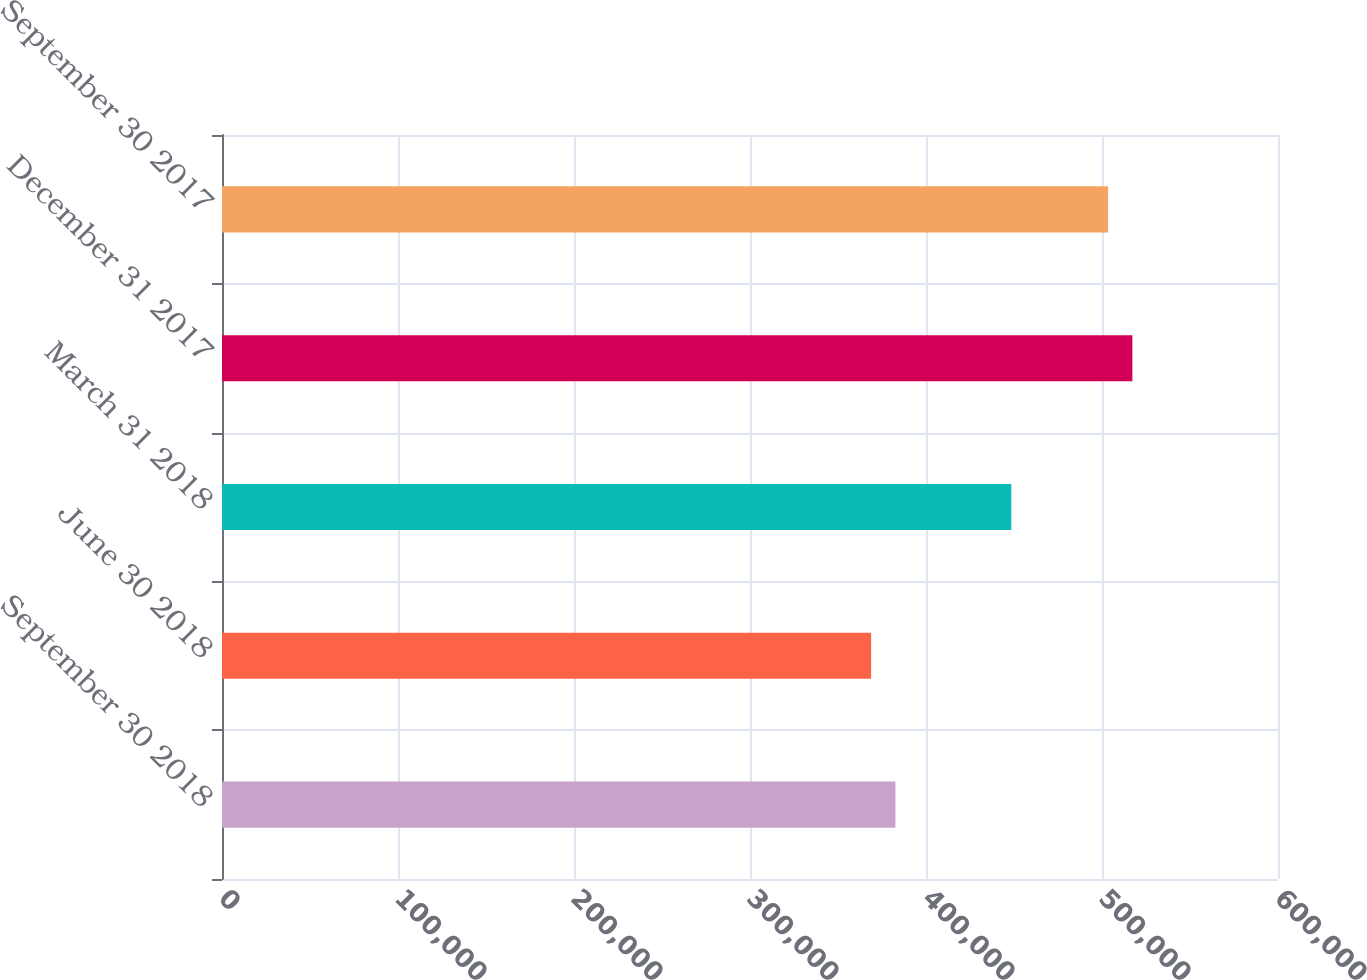<chart> <loc_0><loc_0><loc_500><loc_500><bar_chart><fcel>September 30 2018<fcel>June 30 2018<fcel>March 31 2018<fcel>December 31 2017<fcel>September 30 2017<nl><fcel>382611<fcel>368822<fcel>448474<fcel>517251<fcel>503462<nl></chart> 